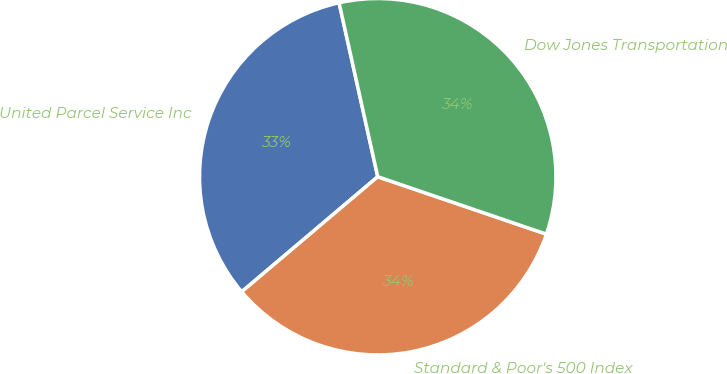Convert chart. <chart><loc_0><loc_0><loc_500><loc_500><pie_chart><fcel>United Parcel Service Inc<fcel>Standard & Poor's 500 Index<fcel>Dow Jones Transportation<nl><fcel>32.69%<fcel>33.6%<fcel>33.7%<nl></chart> 